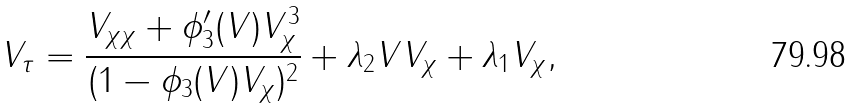Convert formula to latex. <formula><loc_0><loc_0><loc_500><loc_500>V _ { \tau } = \frac { V _ { \chi \chi } + \phi _ { 3 } ^ { \prime } ( V ) V _ { \chi } ^ { 3 } } { ( 1 - \phi _ { 3 } ( V ) V _ { \chi } ) ^ { 2 } } + \lambda _ { 2 } V V _ { \chi } + \lambda _ { 1 } V _ { \chi } ,</formula> 